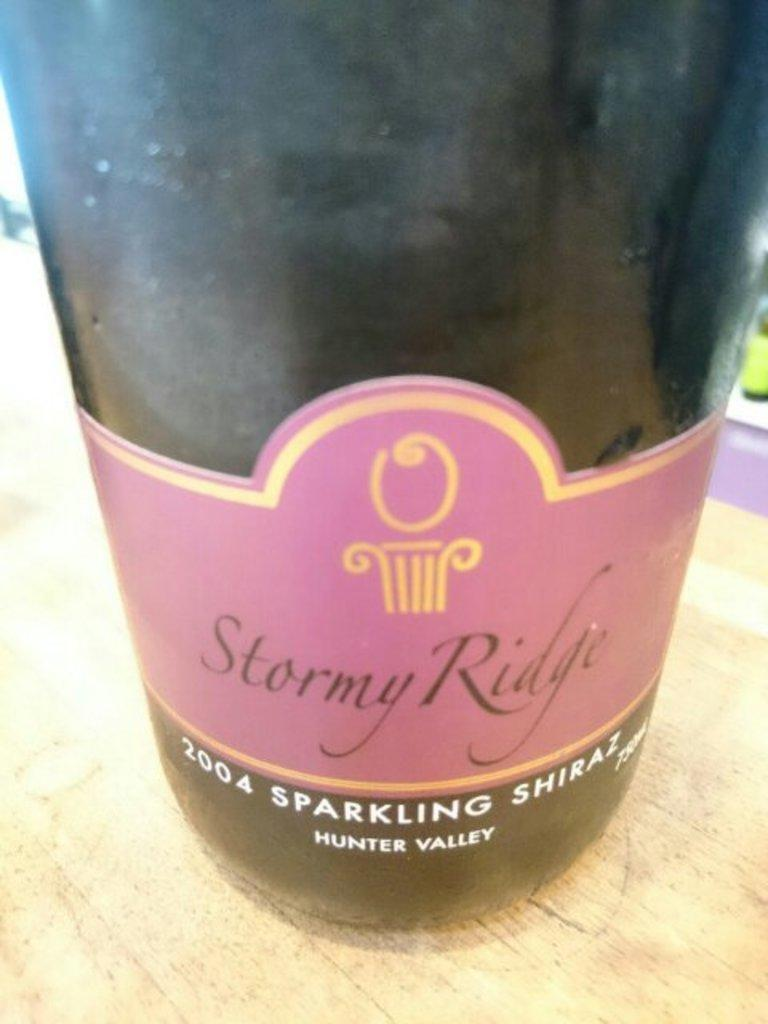<image>
Offer a succinct explanation of the picture presented. A bottle of 2004 Sparkling Shiraz from Stormy Ridge. 